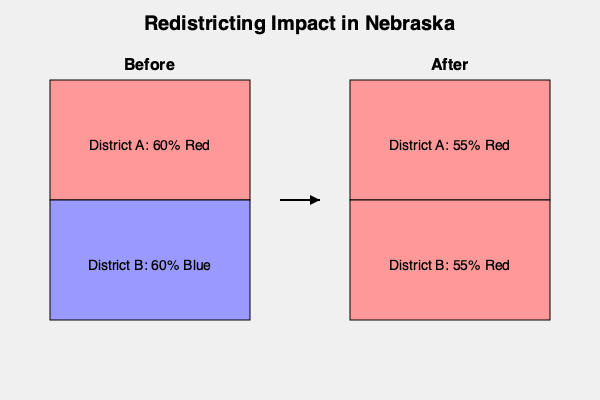Based on the redistricting map of Nebraska shown above, calculate the efficiency gap between the two parties after redistricting. How does this change in efficiency gap reflect on the fairness of the new district boundaries? To calculate the efficiency gap and assess the fairness of the new district boundaries, we'll follow these steps:

1. Understand the concept: The efficiency gap measures the difference in wasted votes between parties.

2. Calculate wasted votes for each party in each district:
   - Wasted votes = Votes above 50% + All votes for the losing party
   - District A: Red wastes 5%, Blue wastes 45%
   - District B: Red wastes 5%, Blue wastes 45%

3. Sum up wasted votes for each party:
   - Red: 5% + 5% = 10%
   - Blue: 45% + 45% = 90%

4. Calculate the efficiency gap:
   $$ \text{Efficiency Gap} = \frac{\text{Total Wasted Votes}_{\text{Blue}} - \text{Total Wasted Votes}_{\text{Red}}}{\text{Total Votes}} $$
   $$ \text{Efficiency Gap} = \frac{90\% - 10\%}{200\%} = 40\% $$

5. Interpret the result:
   - An efficiency gap of 40% favoring the Red party indicates a significant partisan bias in the new district boundaries.
   - Generally, an efficiency gap above 7-8% is considered problematic for fair representation.

6. Compare to before redistricting:
   - Before, each party had one safe district, resulting in a more balanced representation.
   - After redistricting, both districts favor the Red party, despite overall voter preferences being evenly split.

7. Assess fairness:
   - The high efficiency gap suggests that the new boundaries unfairly advantage the Red party.
   - This redistricting appears to be an example of gerrymandering, where district boundaries are manipulated to favor one party over another.
Answer: 40% efficiency gap favoring Red party; significant partisan bias indicating unfair redistricting. 